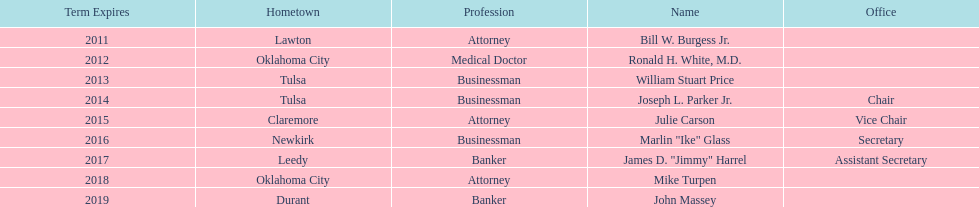Which state regent is from the same hometown as ronald h. white, m.d.? Mike Turpen. 